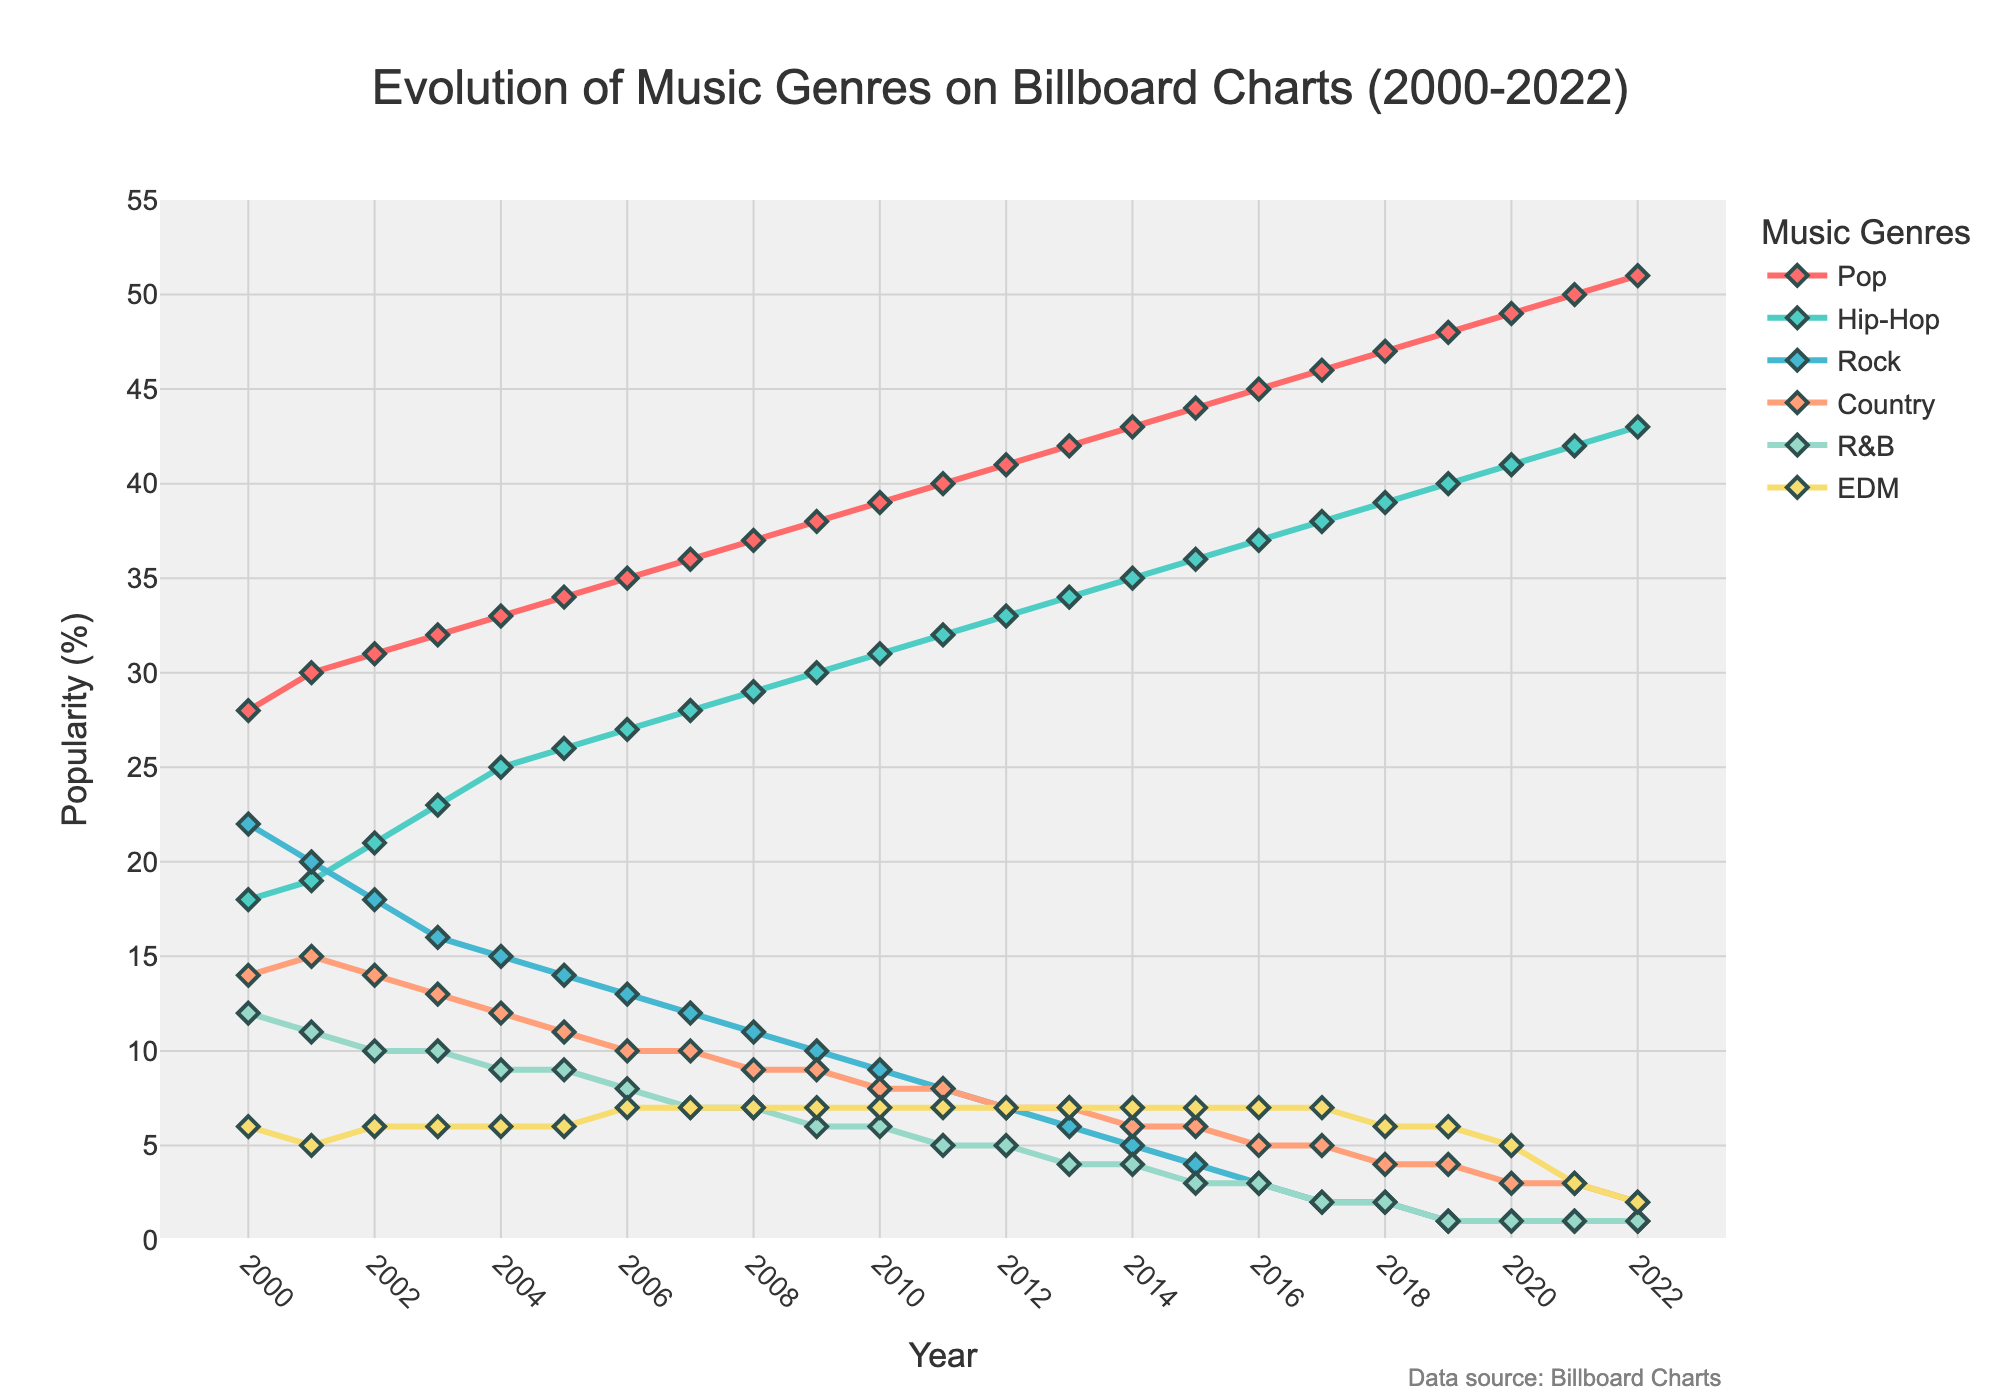Which genre has consistently increased in popularity from 2000 to 2022? By looking at each genre's line over the years, Pop genre shows a consistent upward trend, increasing from 28% in 2000 to 51% in 2022 without any fluctuations or declines.
Answer: Pop What is the combined popularity percentage of Hip-Hop and EDM in 2015? In 2015, Hip-Hop is at 36% and EDM is at 7%. Adding these together, the combined popularity is 36 + 7 = 43%.
Answer: 43% Which genre had the biggest decline in popularity from 2000 to 2022? By comparing the start and end values for each genre, Rock genre declined the most, from 22% in 2000 to 1% in 2022.
Answer: Rock How did the popularity of Country change from 2000 to 2022? In 2000, Country had 14% popularity, and by 2022, it dropped to 2%. The popularity decreased by 14 - 2 = 12%.
Answer: -12% Which genre showed the smallest range in popularity values from 2000 to 2022? By inspecting the lines and their ranges, EDM remained within the narrowest range from 6% to 7%, fluctuating the least compared to other genres.
Answer: EDM In what year did Pop surpass the 40% popularity mark? Looking at Pop's trend line, Pop surpasses 40% in the year 2011.
Answer: 2011 What is the difference in popularity between Hip-Hop and R&B in 2020? In 2020, Hip-Hop is at 41% and R&B is at 1%, so the difference is 41 - 1 = 40%.
Answer: 40% Which genre was more popular in 2010, Rock or Country? And by how much? In 2010, Rock was at 9% and Country was at 8%, so Rock was more popular by 1%.
Answer: Rock, by 1% When did the popularity of Rock fall below 10%? Looking at Rock's decline, it dropped below 10% in the year 2009.
Answer: 2009 How did R&B's popularity change between 2000 and 2014? In 2000, R&B had 12% popularity and by 2014, it dropped to 4%. Change = 12 - 4 = 8% decrease over the period.
Answer: -8% 